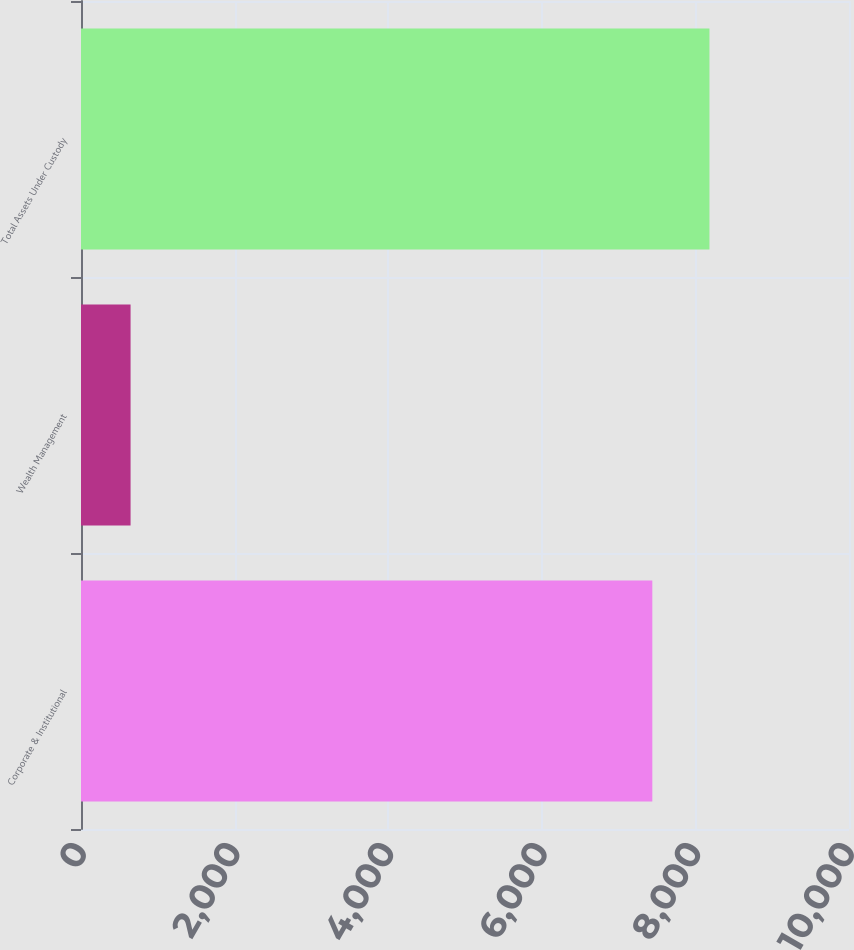<chart> <loc_0><loc_0><loc_500><loc_500><bar_chart><fcel>Corporate & Institutional<fcel>Wealth Management<fcel>Total Assets Under Custody<nl><fcel>7439.1<fcel>645.5<fcel>8183.01<nl></chart> 